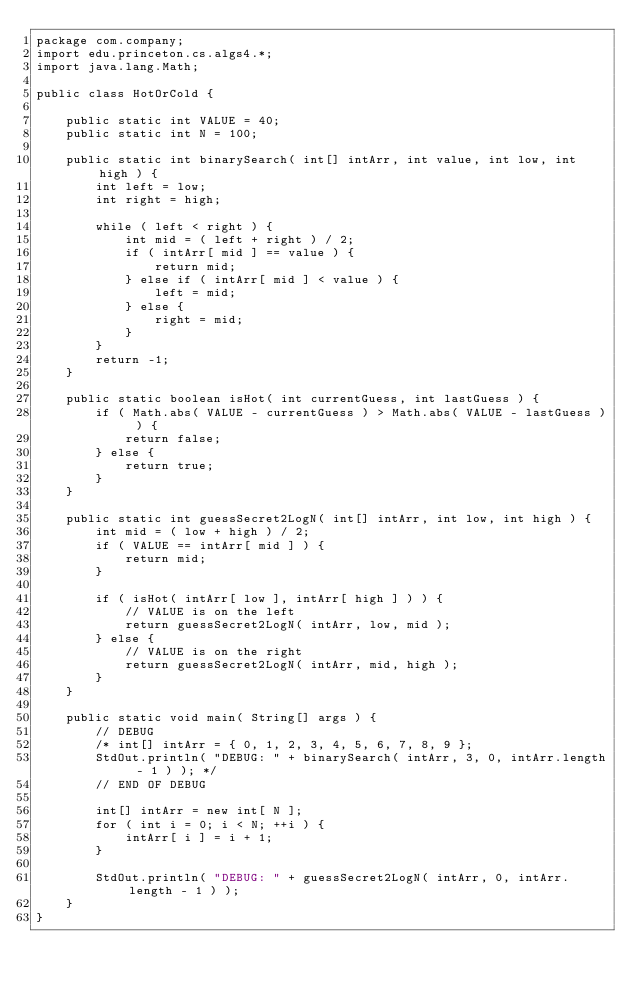Convert code to text. <code><loc_0><loc_0><loc_500><loc_500><_Java_>package com.company;
import edu.princeton.cs.algs4.*;
import java.lang.Math;

public class HotOrCold {

    public static int VALUE = 40;
    public static int N = 100;

    public static int binarySearch( int[] intArr, int value, int low, int high ) {
        int left = low;
        int right = high;

        while ( left < right ) {
            int mid = ( left + right ) / 2;
            if ( intArr[ mid ] == value ) {
                return mid;
            } else if ( intArr[ mid ] < value ) {
                left = mid;
            } else {
                right = mid;
            }
        }
        return -1;
    }

    public static boolean isHot( int currentGuess, int lastGuess ) {
        if ( Math.abs( VALUE - currentGuess ) > Math.abs( VALUE - lastGuess ) ) {
            return false;
        } else {
            return true;
        }
    }

    public static int guessSecret2LogN( int[] intArr, int low, int high ) {
        int mid = ( low + high ) / 2;
        if ( VALUE == intArr[ mid ] ) {
            return mid;
        }

        if ( isHot( intArr[ low ], intArr[ high ] ) ) {
            // VALUE is on the left
            return guessSecret2LogN( intArr, low, mid );
        } else {
            // VALUE is on the right
            return guessSecret2LogN( intArr, mid, high );
        }
    }

    public static void main( String[] args ) {
        // DEBUG
        /* int[] intArr = { 0, 1, 2, 3, 4, 5, 6, 7, 8, 9 };
        StdOut.println( "DEBUG: " + binarySearch( intArr, 3, 0, intArr.length - 1 ) ); */
        // END OF DEBUG

        int[] intArr = new int[ N ];
        for ( int i = 0; i < N; ++i ) {
            intArr[ i ] = i + 1;
        }

        StdOut.println( "DEBUG: " + guessSecret2LogN( intArr, 0, intArr.length - 1 ) );
    }
}
</code> 